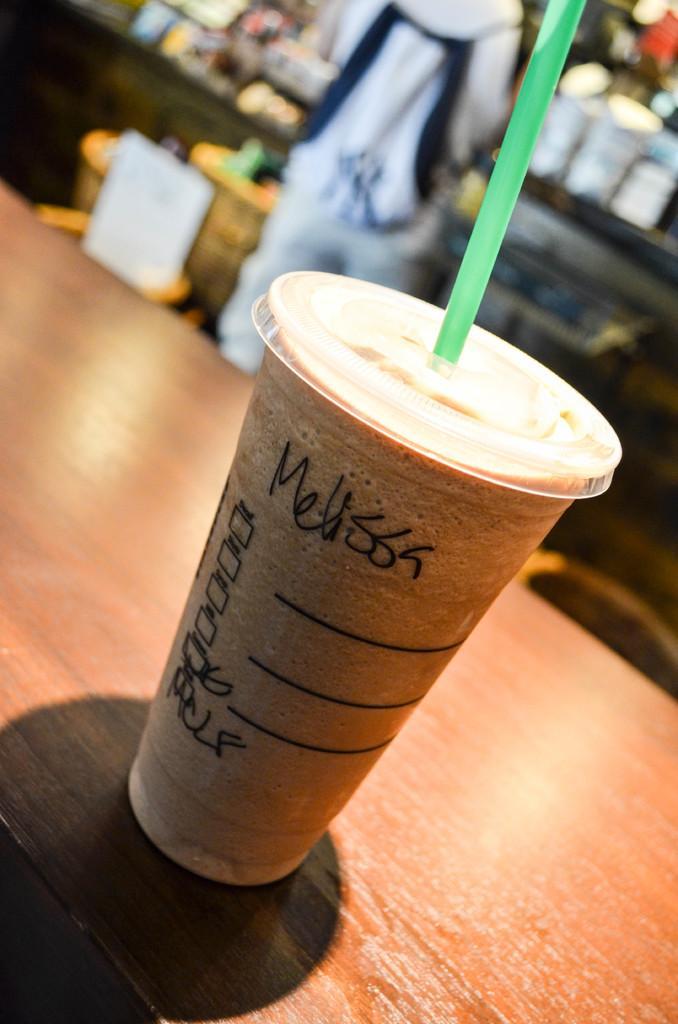How would you summarize this image in a sentence or two? In this picture we can see a cup on the table and we can see drink in the cup, in the background we can see a person and few other things. 